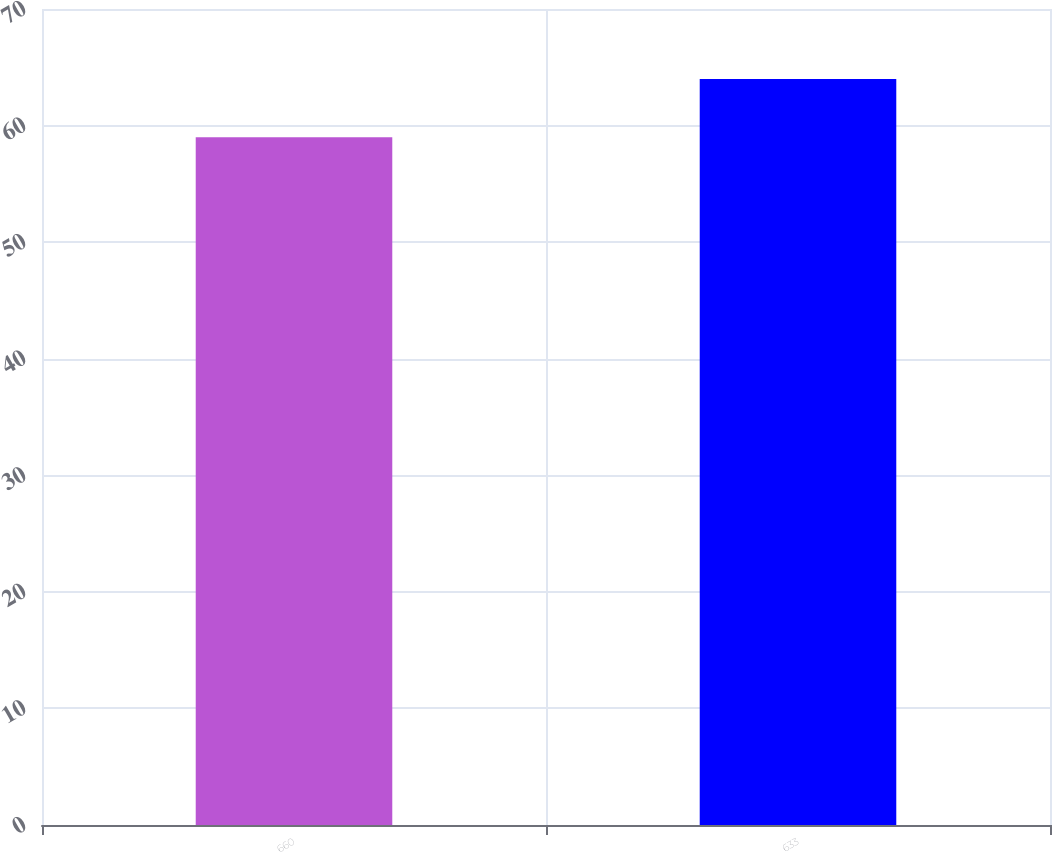Convert chart. <chart><loc_0><loc_0><loc_500><loc_500><bar_chart><fcel>660<fcel>633<nl><fcel>59<fcel>64<nl></chart> 